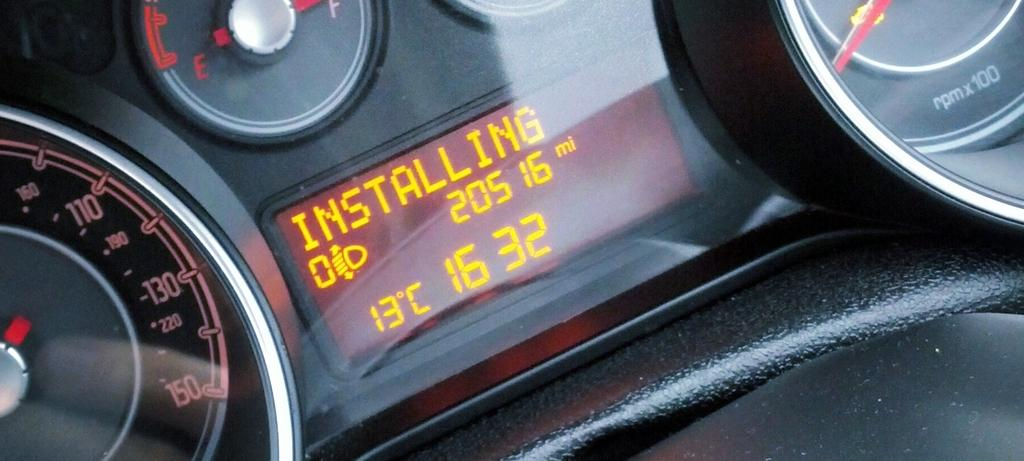What type of instruments are shown in the image? There are vehicle gauges in the image. What else can be seen in the image besides the vehicle gauges? There is a screen in the image. How many fingers can be seen pointing at the vehicle gauges in the image? There are no fingers visible in the image, as it only shows vehicle gauges and a screen. 